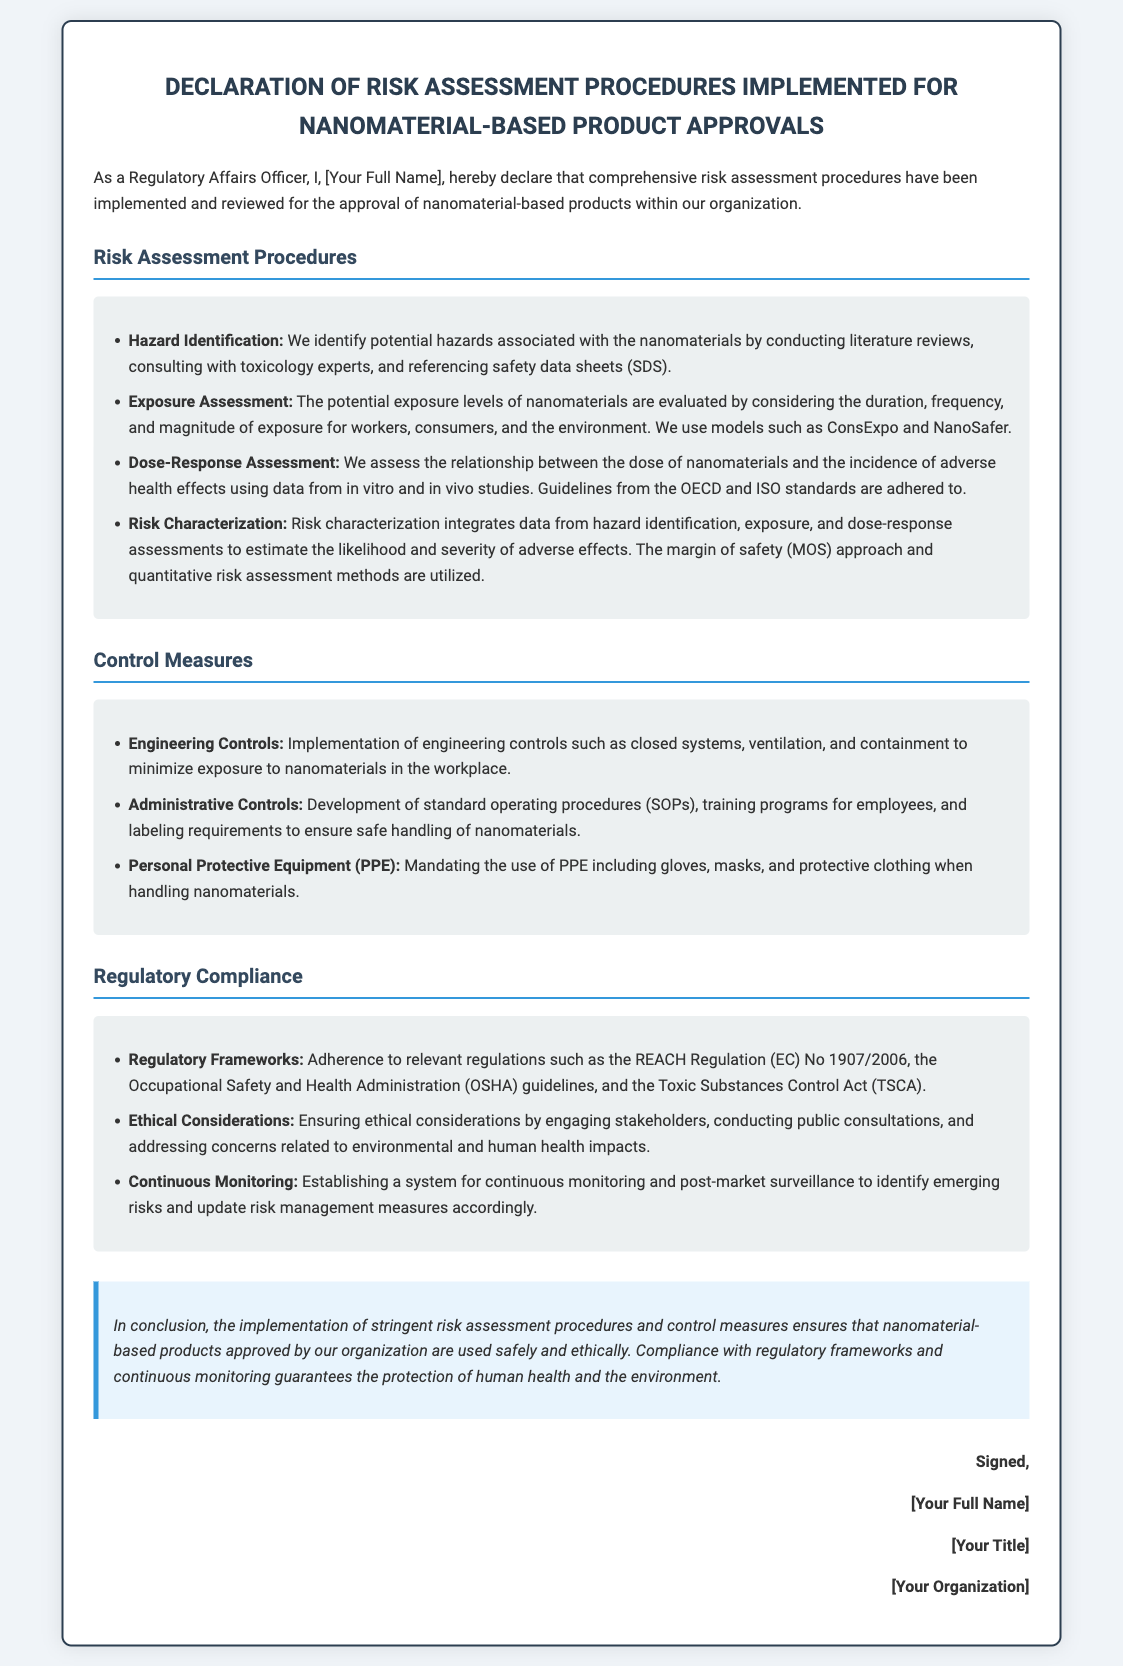what is the title of the document? The title appears at the top of the declaration and identifies the subject matter related to risk assessment procedures for nanomaterials.
Answer: Declaration of Risk Assessment Procedures for Nanomaterial-Based Products who is responsible for ensuring the safe and ethical use of nanomaterials? The declaration is made by a Regulatory Affairs Officer responsible for the procedures discussed in the document.
Answer: [Your Full Name] what is the first step in the risk assessment procedures? The document outlines a series of procedures, with hazard identification listed as the first step in the risk assessment process.
Answer: Hazard Identification which regulation is mentioned for compliance? The document refers to specific regulations relevant to nanomaterials, naming one as an example.
Answer: REACH Regulation (EC) No 1907/2006 what type of controls are mentioned to minimize exposure to nanomaterials? The document includes categories of controls to ensure safety, highlighting engineering controls as a primary measure.
Answer: Engineering Controls what is the margin of safety approach used for? The document states that this approach is a method within risk characterization to assess safety in the risk assessment process for nanomaterials.
Answer: Risk Characterization how many main sections are there in the risk assessment procedures? The document divides the risk assessment into a few key areas, asking for the number of distinct sections ultimately listed.
Answer: Four who has to adhere to the ethical considerations mentioned? The document specifies the need for stakeholder engagement, thus reflecting a responsible approach to approvals, highlighting who is involved in this process.
Answer: Stakeholders what does the conclusion emphasize about nanomaterial-based products? The conclusion summarizes the overall stance and commitments made in the document regarding safety and ethics in product approval.
Answer: Used safely and ethically 